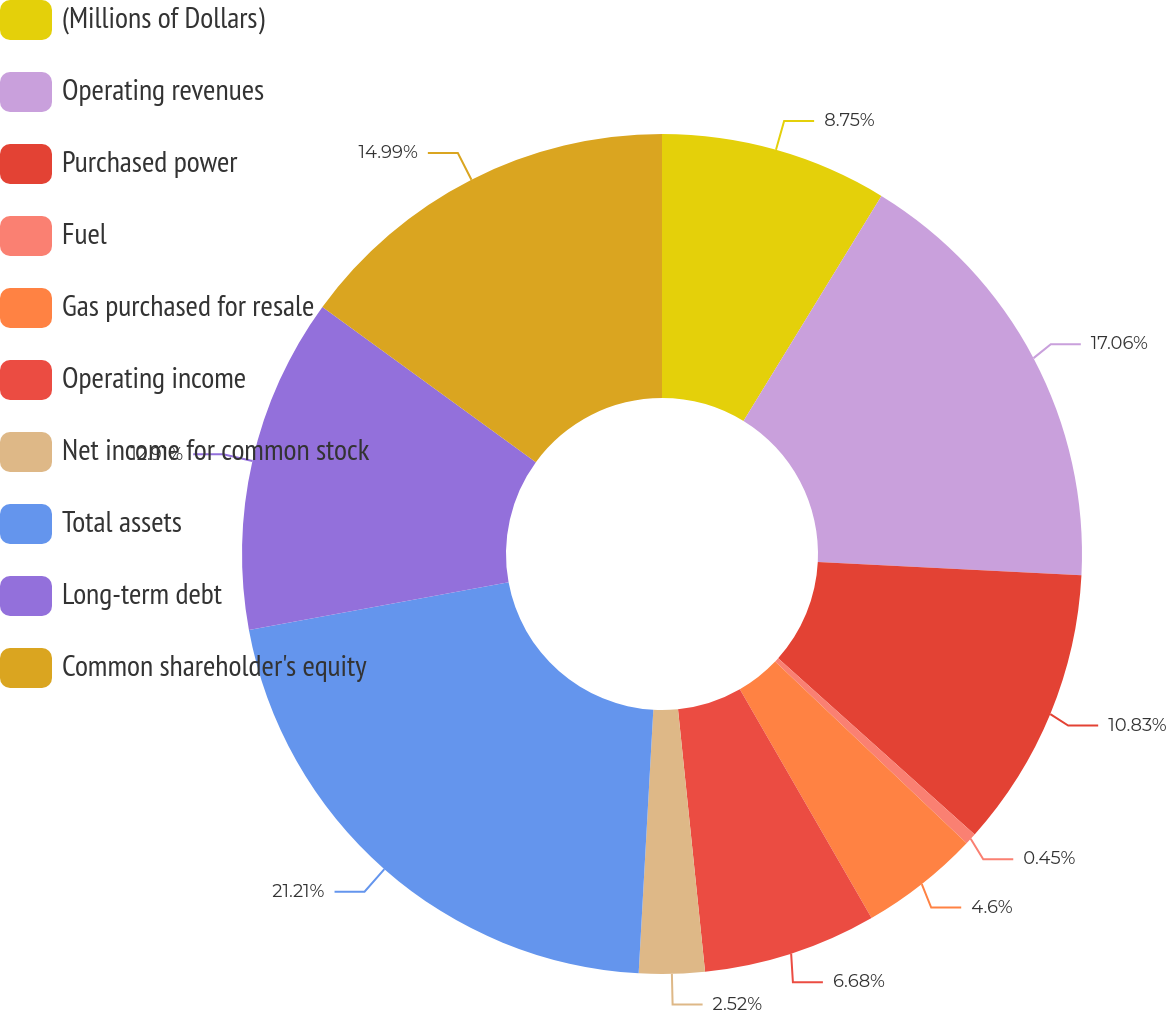<chart> <loc_0><loc_0><loc_500><loc_500><pie_chart><fcel>(Millions of Dollars)<fcel>Operating revenues<fcel>Purchased power<fcel>Fuel<fcel>Gas purchased for resale<fcel>Operating income<fcel>Net income for common stock<fcel>Total assets<fcel>Long-term debt<fcel>Common shareholder's equity<nl><fcel>8.75%<fcel>17.06%<fcel>10.83%<fcel>0.45%<fcel>4.6%<fcel>6.68%<fcel>2.52%<fcel>21.22%<fcel>12.91%<fcel>14.99%<nl></chart> 